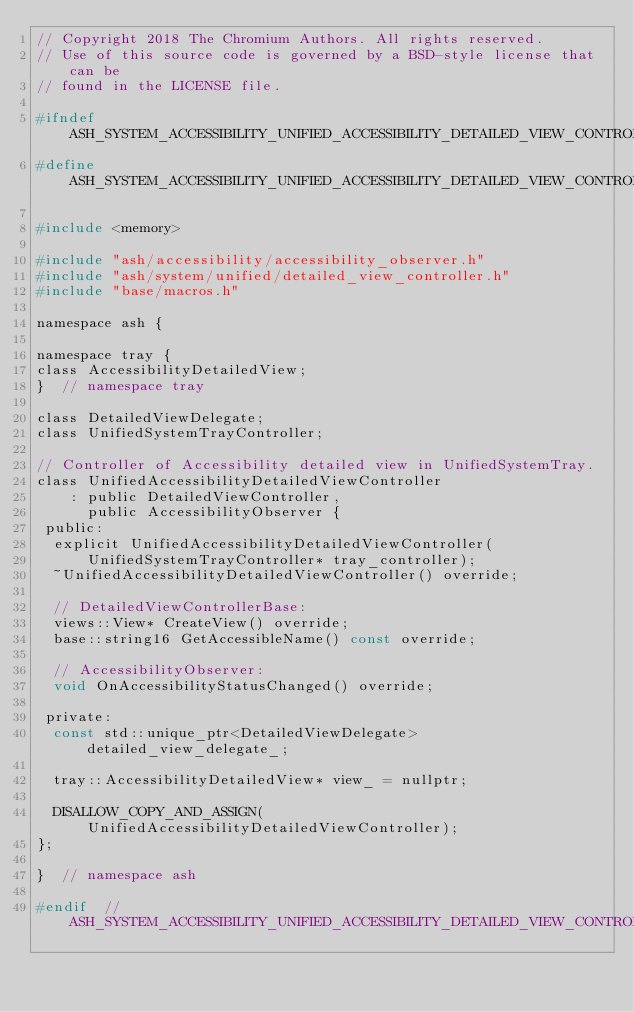<code> <loc_0><loc_0><loc_500><loc_500><_C_>// Copyright 2018 The Chromium Authors. All rights reserved.
// Use of this source code is governed by a BSD-style license that can be
// found in the LICENSE file.

#ifndef ASH_SYSTEM_ACCESSIBILITY_UNIFIED_ACCESSIBILITY_DETAILED_VIEW_CONTROLLER_H_
#define ASH_SYSTEM_ACCESSIBILITY_UNIFIED_ACCESSIBILITY_DETAILED_VIEW_CONTROLLER_H_

#include <memory>

#include "ash/accessibility/accessibility_observer.h"
#include "ash/system/unified/detailed_view_controller.h"
#include "base/macros.h"

namespace ash {

namespace tray {
class AccessibilityDetailedView;
}  // namespace tray

class DetailedViewDelegate;
class UnifiedSystemTrayController;

// Controller of Accessibility detailed view in UnifiedSystemTray.
class UnifiedAccessibilityDetailedViewController
    : public DetailedViewController,
      public AccessibilityObserver {
 public:
  explicit UnifiedAccessibilityDetailedViewController(
      UnifiedSystemTrayController* tray_controller);
  ~UnifiedAccessibilityDetailedViewController() override;

  // DetailedViewControllerBase:
  views::View* CreateView() override;
  base::string16 GetAccessibleName() const override;

  // AccessibilityObserver:
  void OnAccessibilityStatusChanged() override;

 private:
  const std::unique_ptr<DetailedViewDelegate> detailed_view_delegate_;

  tray::AccessibilityDetailedView* view_ = nullptr;

  DISALLOW_COPY_AND_ASSIGN(UnifiedAccessibilityDetailedViewController);
};

}  // namespace ash

#endif  // ASH_SYSTEM_ACCESSIBILITY_UNIFIED_ACCESSIBILITY_DETAILED_VIEW_CONTROLLER_H_
</code> 